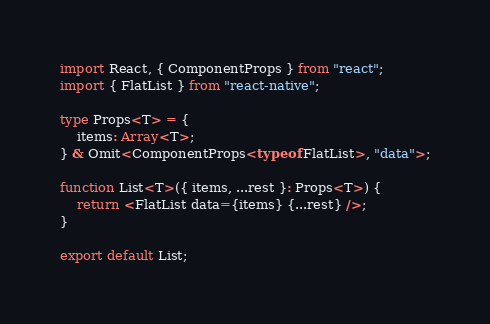Convert code to text. <code><loc_0><loc_0><loc_500><loc_500><_TypeScript_>import React, { ComponentProps } from "react";
import { FlatList } from "react-native";

type Props<T> = {
	items: Array<T>;
} & Omit<ComponentProps<typeof FlatList>, "data">;

function List<T>({ items, ...rest }: Props<T>) {
	return <FlatList data={items} {...rest} />;
}

export default List;
</code> 